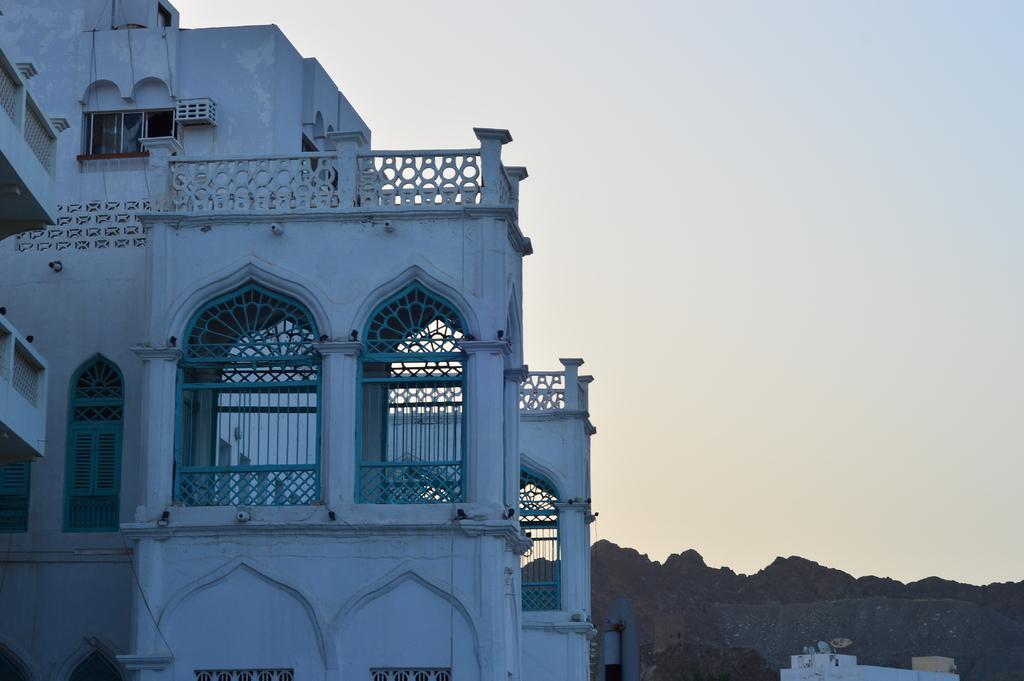Can you describe this image briefly? In the image there is a building in the foreground and behind the building there are mountains. 